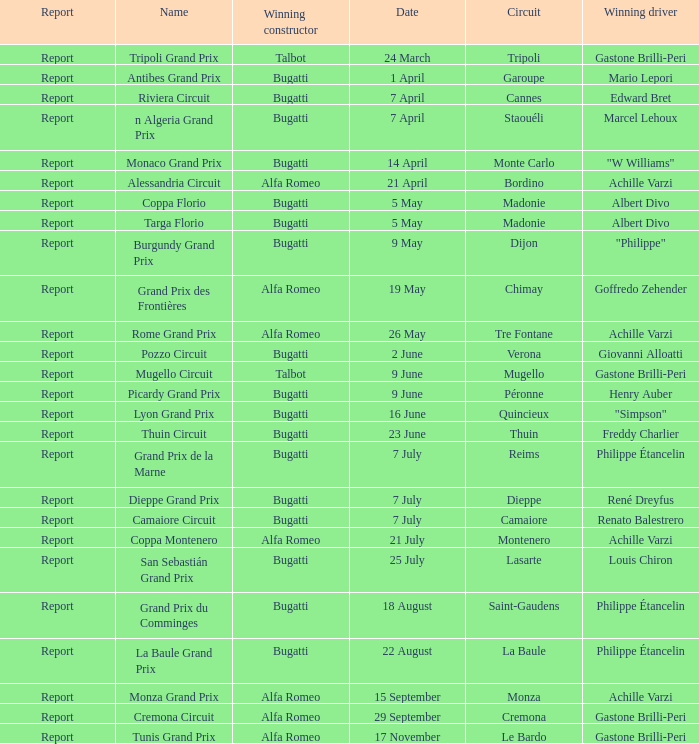What Circuit has a Date of 25 july? Lasarte. 